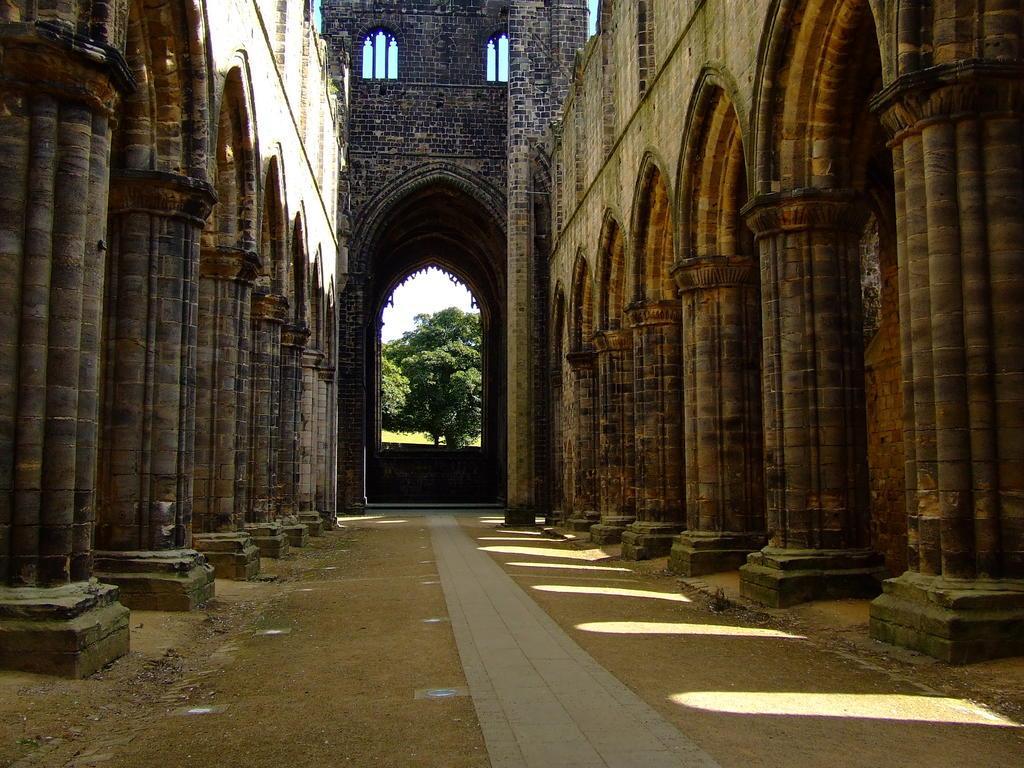Can you describe this image briefly? In the center of the image there is a tower and we can see pillars. At the bottom there is an arch and we can see a tree. In the background there is sky. 